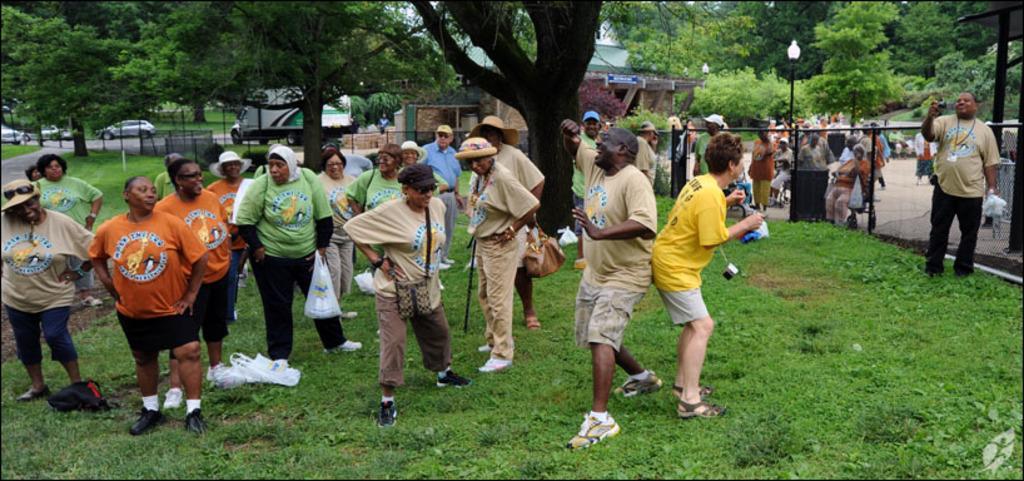Please provide a concise description of this image. In this picture there are people on the right and left side of the image, on the grass floor and there are trees at the top side of the image, there are cars on the left side of the image. 